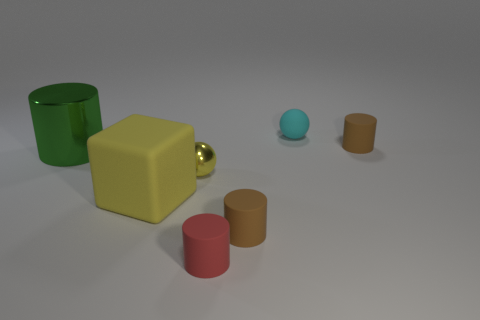Is the number of tiny objects that are to the left of the large green thing less than the number of large yellow spheres?
Your answer should be very brief. No. There is a large matte cube that is in front of the big green metal cylinder; what number of red things are behind it?
Your response must be concise. 0. What number of other objects are the same size as the cyan matte thing?
Ensure brevity in your answer.  4. What number of things are tiny red rubber blocks or brown rubber things in front of the green thing?
Ensure brevity in your answer.  1. Is the number of rubber cubes less than the number of large red matte cubes?
Your response must be concise. No. There is a object that is behind the brown thing behind the tiny metal thing; what is its color?
Offer a very short reply. Cyan. What is the material of the other thing that is the same shape as the tiny yellow object?
Provide a short and direct response. Rubber. How many matte objects are big green cylinders or cylinders?
Your response must be concise. 3. Do the ball behind the small yellow object and the brown cylinder in front of the green shiny object have the same material?
Give a very brief answer. Yes. Are any metal blocks visible?
Make the answer very short. No. 